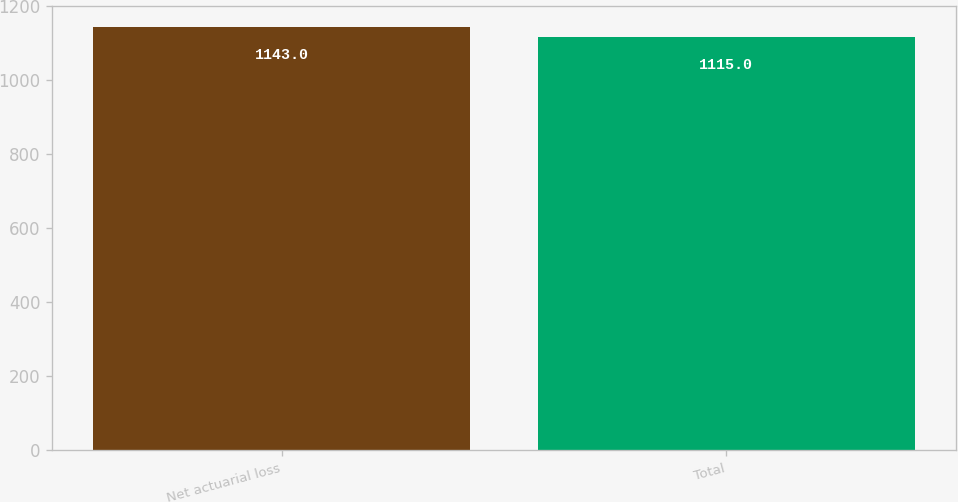Convert chart. <chart><loc_0><loc_0><loc_500><loc_500><bar_chart><fcel>Net actuarial loss<fcel>Total<nl><fcel>1143<fcel>1115<nl></chart> 